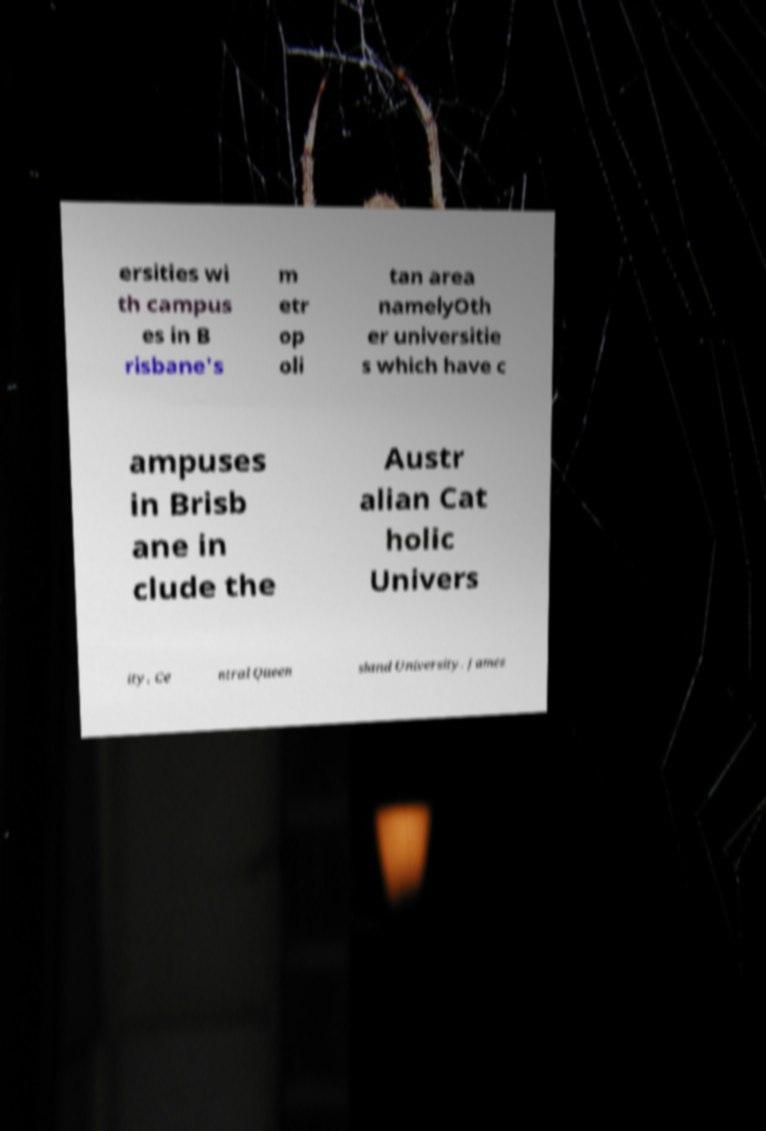Please identify and transcribe the text found in this image. ersities wi th campus es in B risbane's m etr op oli tan area namelyOth er universitie s which have c ampuses in Brisb ane in clude the Austr alian Cat holic Univers ity, Ce ntral Queen sland University, James 